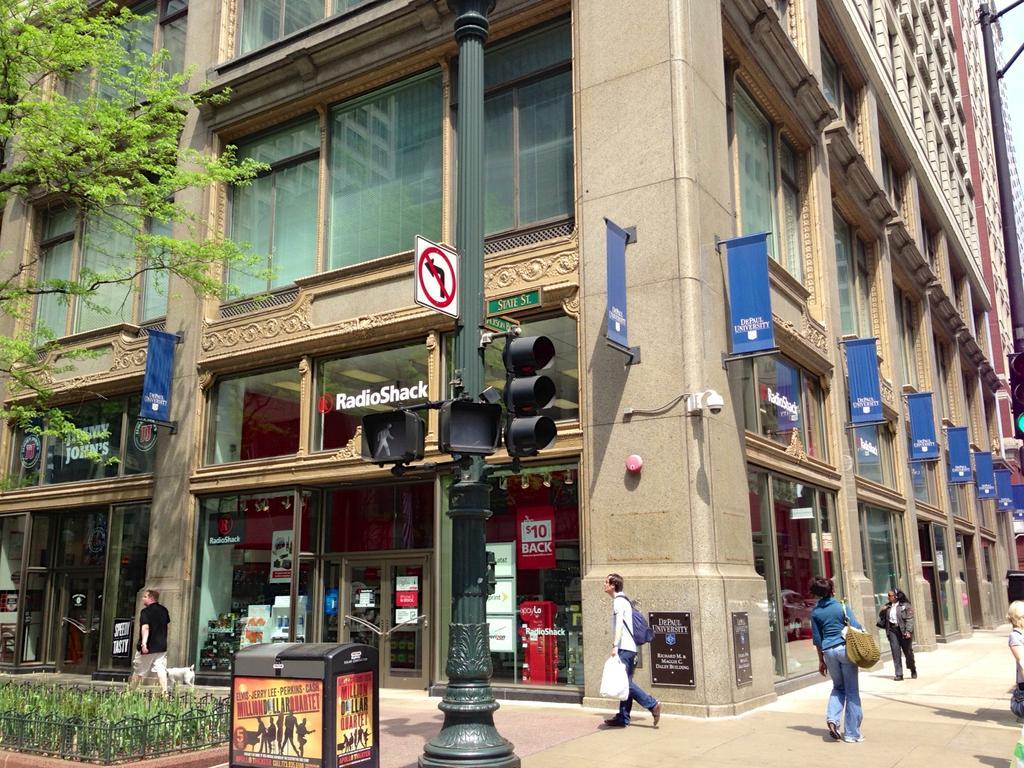Can you describe this image briefly? In this image we can see building with glass window and banners are attached to the building. There is a signal pole in the foreground of the image. We can see people are moving on the pavement. In the left bottom of the image, we can see grass and one black color box. There is a tree on the left side of the image. 